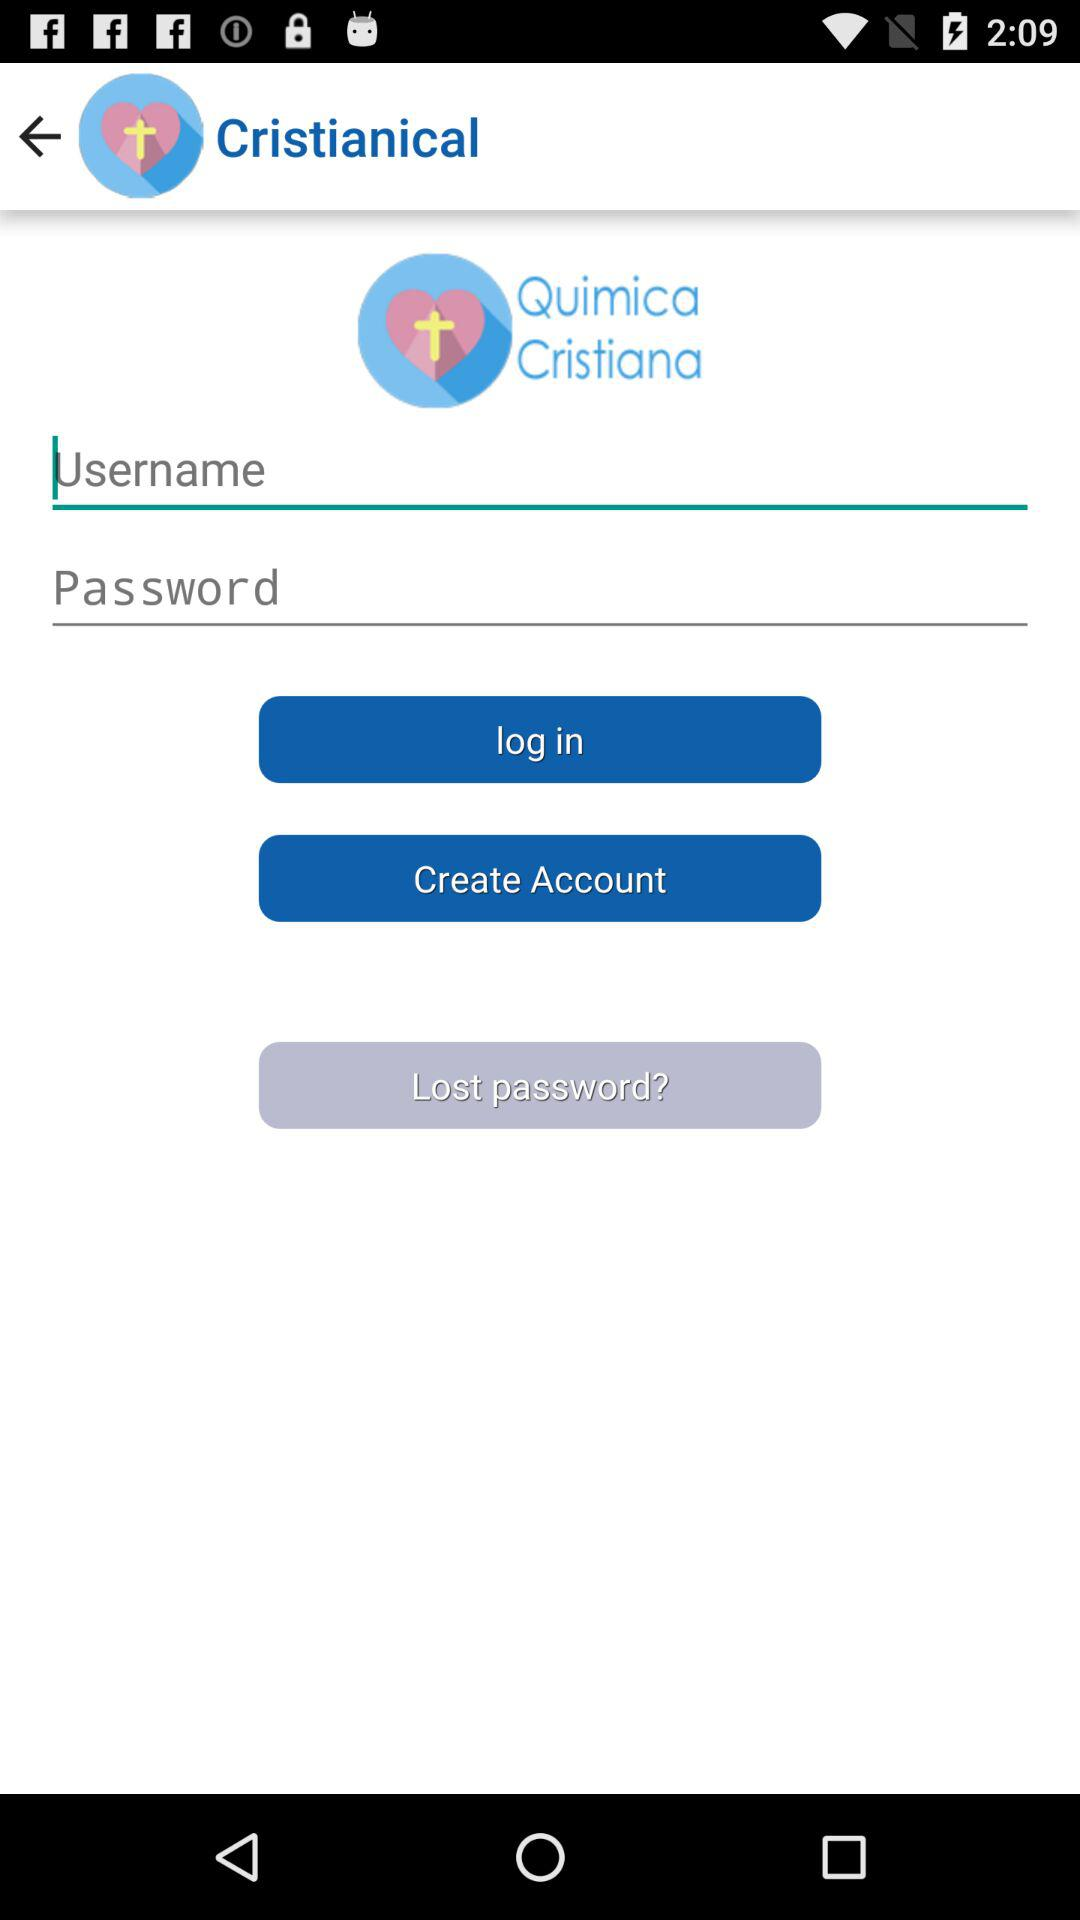Can we reset password?
When the provided information is insufficient, respond with <no answer>. <no answer> 